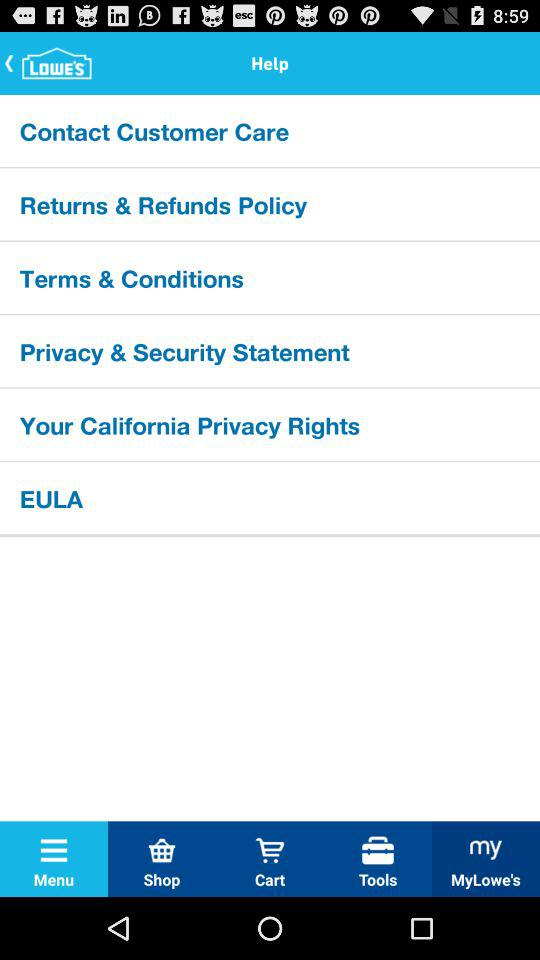What is the application name? The application name is "LOWE'S". 